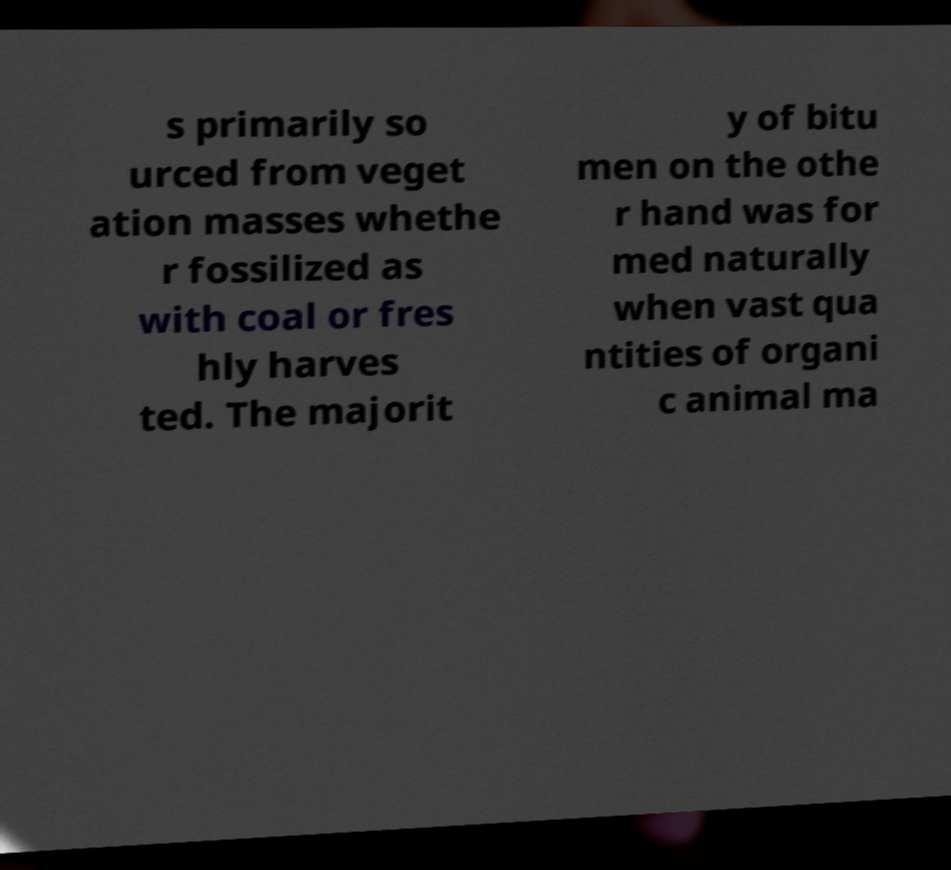Can you accurately transcribe the text from the provided image for me? s primarily so urced from veget ation masses whethe r fossilized as with coal or fres hly harves ted. The majorit y of bitu men on the othe r hand was for med naturally when vast qua ntities of organi c animal ma 